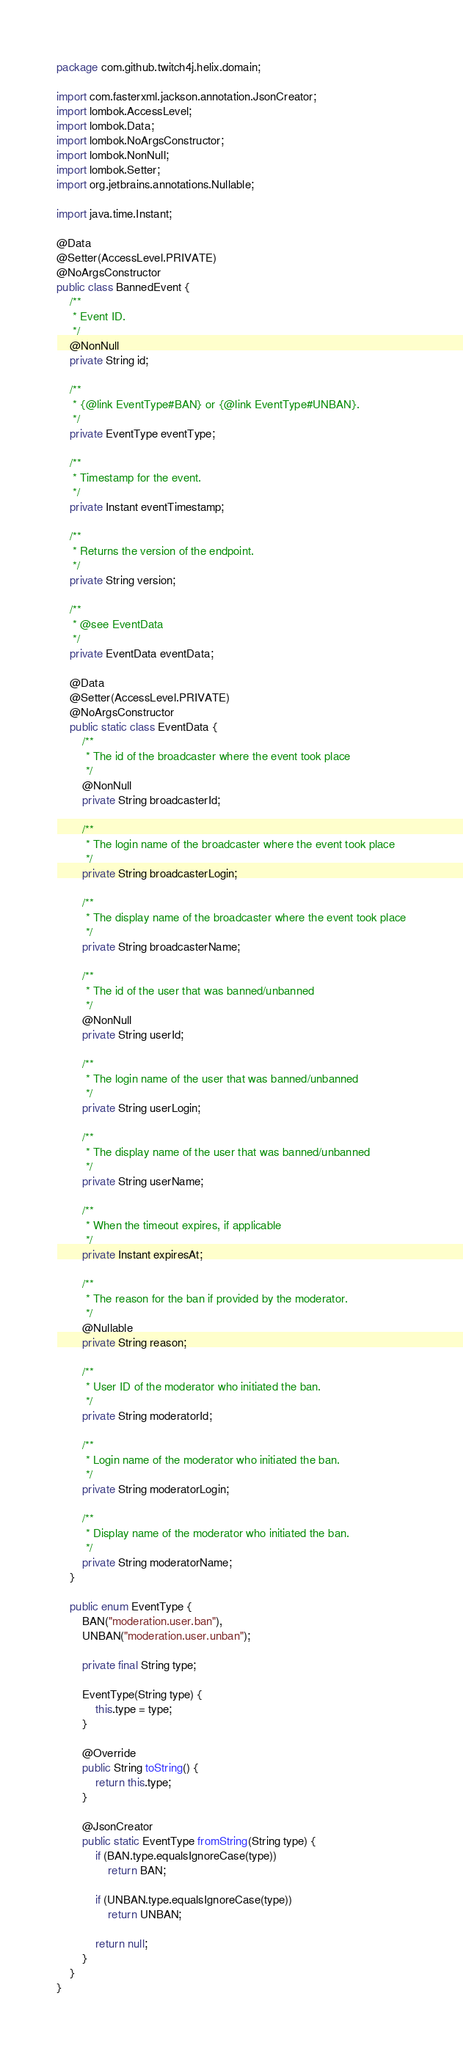<code> <loc_0><loc_0><loc_500><loc_500><_Java_>package com.github.twitch4j.helix.domain;

import com.fasterxml.jackson.annotation.JsonCreator;
import lombok.AccessLevel;
import lombok.Data;
import lombok.NoArgsConstructor;
import lombok.NonNull;
import lombok.Setter;
import org.jetbrains.annotations.Nullable;

import java.time.Instant;

@Data
@Setter(AccessLevel.PRIVATE)
@NoArgsConstructor
public class BannedEvent {
    /**
     * Event ID.
     */
    @NonNull
    private String id;

    /**
     * {@link EventType#BAN} or {@link EventType#UNBAN}.
     */
    private EventType eventType;

    /**
     * Timestamp for the event.
     */
    private Instant eventTimestamp;

    /**
     * Returns the version of the endpoint.
     */
    private String version;

    /**
     * @see EventData
     */
    private EventData eventData;

    @Data
    @Setter(AccessLevel.PRIVATE)
    @NoArgsConstructor
    public static class EventData {
        /**
         * The id of the broadcaster where the event took place
         */
        @NonNull
        private String broadcasterId;

        /**
         * The login name of the broadcaster where the event took place
         */
        private String broadcasterLogin;

        /**
         * The display name of the broadcaster where the event took place
         */
        private String broadcasterName;

        /**
         * The id of the user that was banned/unbanned
         */
        @NonNull
        private String userId;

        /**
         * The login name of the user that was banned/unbanned
         */
        private String userLogin;

        /**
         * The display name of the user that was banned/unbanned
         */
        private String userName;

        /**
         * When the timeout expires, if applicable
         */
        private Instant expiresAt;

        /**
         * The reason for the ban if provided by the moderator.
         */
        @Nullable
        private String reason;

        /**
         * User ID of the moderator who initiated the ban.
         */
        private String moderatorId;

        /**
         * Login name of the moderator who initiated the ban.
         */
        private String moderatorLogin;

        /**
         * Display name of the moderator who initiated the ban.
         */
        private String moderatorName;
    }

    public enum EventType {
        BAN("moderation.user.ban"),
        UNBAN("moderation.user.unban");

        private final String type;

        EventType(String type) {
            this.type = type;
        }

        @Override
        public String toString() {
            return this.type;
        }

        @JsonCreator
        public static EventType fromString(String type) {
            if (BAN.type.equalsIgnoreCase(type))
                return BAN;

            if (UNBAN.type.equalsIgnoreCase(type))
                return UNBAN;

            return null;
        }
    }
}
</code> 